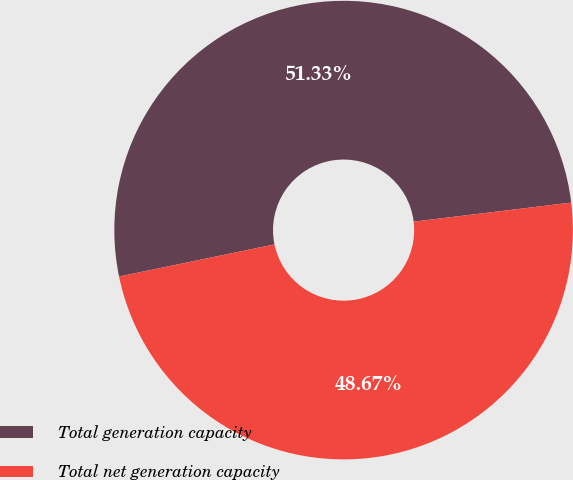Convert chart to OTSL. <chart><loc_0><loc_0><loc_500><loc_500><pie_chart><fcel>Total generation capacity<fcel>Total net generation capacity<nl><fcel>51.33%<fcel>48.67%<nl></chart> 